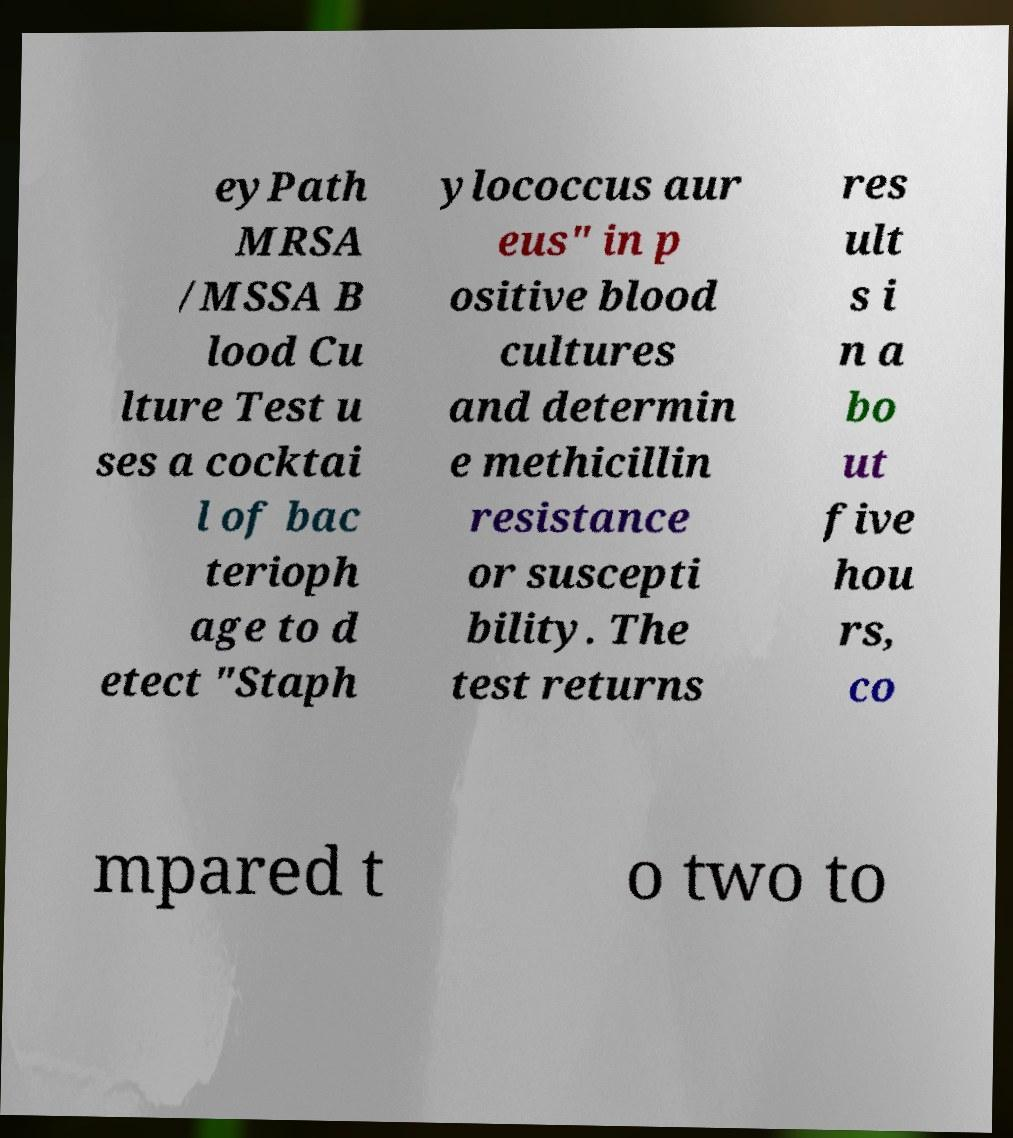Can you read and provide the text displayed in the image?This photo seems to have some interesting text. Can you extract and type it out for me? eyPath MRSA /MSSA B lood Cu lture Test u ses a cocktai l of bac terioph age to d etect "Staph ylococcus aur eus" in p ositive blood cultures and determin e methicillin resistance or suscepti bility. The test returns res ult s i n a bo ut five hou rs, co mpared t o two to 